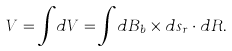<formula> <loc_0><loc_0><loc_500><loc_500>V = { \int } d V = { \int } d B _ { b } \times { d s _ { r } } \cdot { d R } .</formula> 